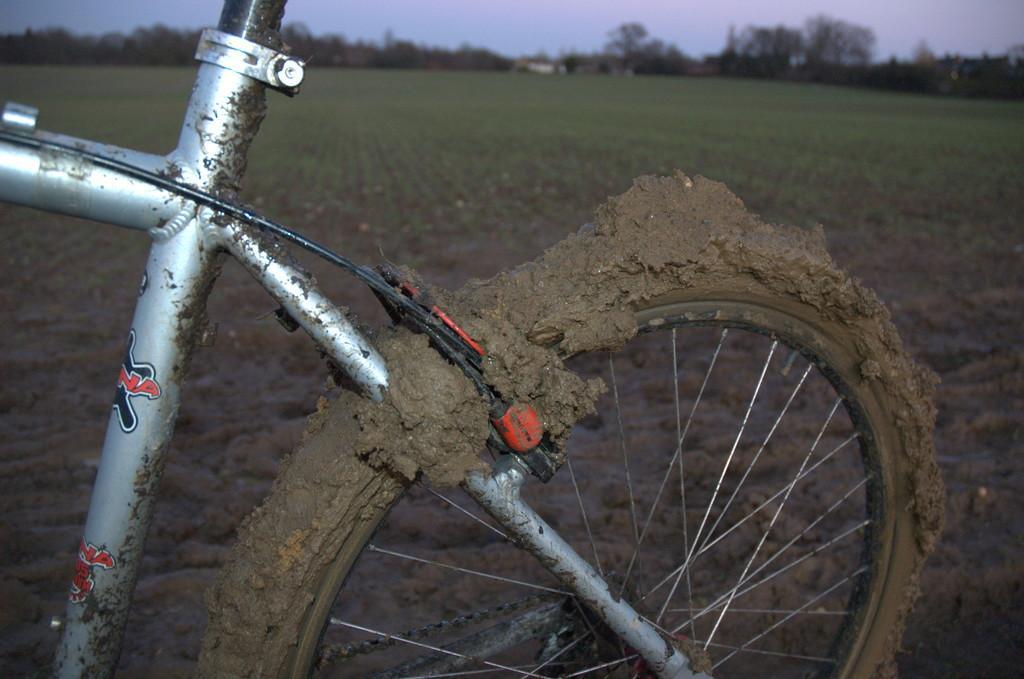How would you summarize this image in a sentence or two? In this image we can see mud clogged bicycle which is in the color of silver and in the background of the image there are some farm lands, trees and clear sky. 